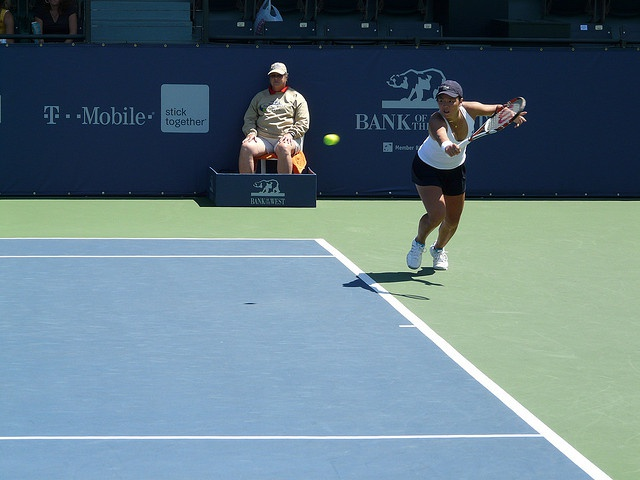Describe the objects in this image and their specific colors. I can see people in black and gray tones, people in black, gray, and ivory tones, people in black, darkblue, and purple tones, tennis racket in black, darkgray, gray, and maroon tones, and people in black, darkgreen, gray, and navy tones in this image. 